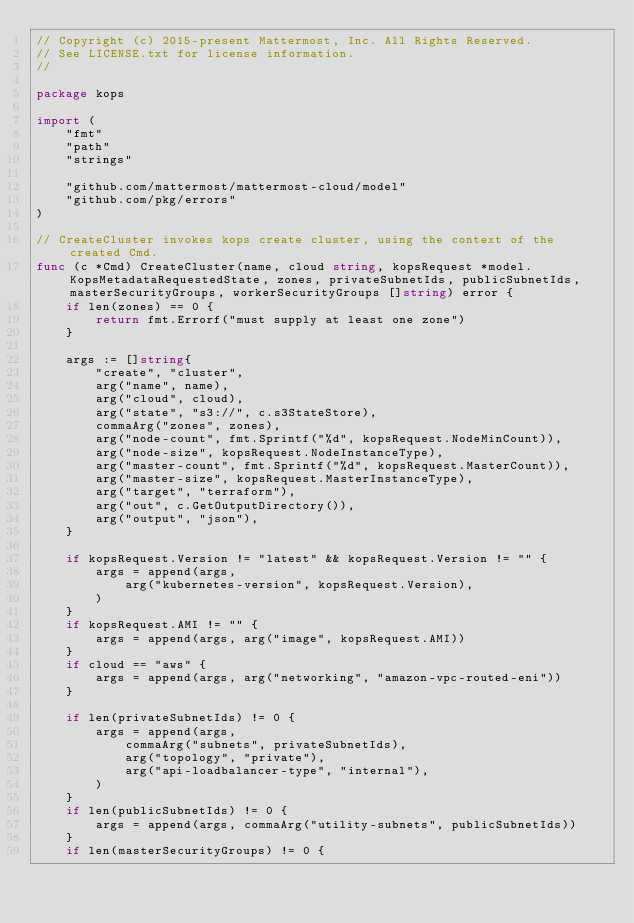<code> <loc_0><loc_0><loc_500><loc_500><_Go_>// Copyright (c) 2015-present Mattermost, Inc. All Rights Reserved.
// See LICENSE.txt for license information.
//

package kops

import (
	"fmt"
	"path"
	"strings"

	"github.com/mattermost/mattermost-cloud/model"
	"github.com/pkg/errors"
)

// CreateCluster invokes kops create cluster, using the context of the created Cmd.
func (c *Cmd) CreateCluster(name, cloud string, kopsRequest *model.KopsMetadataRequestedState, zones, privateSubnetIds, publicSubnetIds, masterSecurityGroups, workerSecurityGroups []string) error {
	if len(zones) == 0 {
		return fmt.Errorf("must supply at least one zone")
	}

	args := []string{
		"create", "cluster",
		arg("name", name),
		arg("cloud", cloud),
		arg("state", "s3://", c.s3StateStore),
		commaArg("zones", zones),
		arg("node-count", fmt.Sprintf("%d", kopsRequest.NodeMinCount)),
		arg("node-size", kopsRequest.NodeInstanceType),
		arg("master-count", fmt.Sprintf("%d", kopsRequest.MasterCount)),
		arg("master-size", kopsRequest.MasterInstanceType),
		arg("target", "terraform"),
		arg("out", c.GetOutputDirectory()),
		arg("output", "json"),
	}

	if kopsRequest.Version != "latest" && kopsRequest.Version != "" {
		args = append(args,
			arg("kubernetes-version", kopsRequest.Version),
		)
	}
	if kopsRequest.AMI != "" {
		args = append(args, arg("image", kopsRequest.AMI))
	}
	if cloud == "aws" {
		args = append(args, arg("networking", "amazon-vpc-routed-eni"))
	}

	if len(privateSubnetIds) != 0 {
		args = append(args,
			commaArg("subnets", privateSubnetIds),
			arg("topology", "private"),
			arg("api-loadbalancer-type", "internal"),
		)
	}
	if len(publicSubnetIds) != 0 {
		args = append(args, commaArg("utility-subnets", publicSubnetIds))
	}
	if len(masterSecurityGroups) != 0 {</code> 